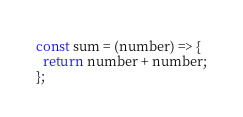<code> <loc_0><loc_0><loc_500><loc_500><_JavaScript_>const sum = (number) => {
  return number + number;
};</code> 